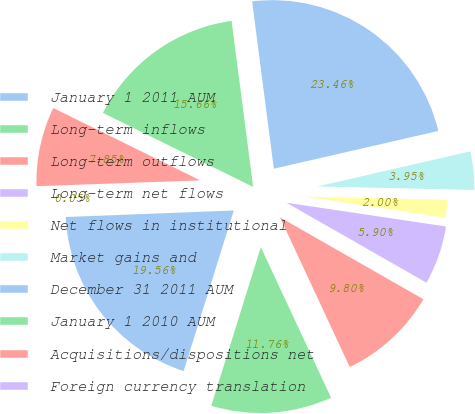<chart> <loc_0><loc_0><loc_500><loc_500><pie_chart><fcel>January 1 2011 AUM<fcel>Long-term inflows<fcel>Long-term outflows<fcel>Long-term net flows<fcel>Net flows in institutional<fcel>Market gains and<fcel>December 31 2011 AUM<fcel>January 1 2010 AUM<fcel>Acquisitions/dispositions net<fcel>Foreign currency translation<nl><fcel>19.56%<fcel>11.76%<fcel>9.8%<fcel>5.9%<fcel>2.0%<fcel>3.95%<fcel>23.46%<fcel>15.66%<fcel>7.85%<fcel>0.05%<nl></chart> 